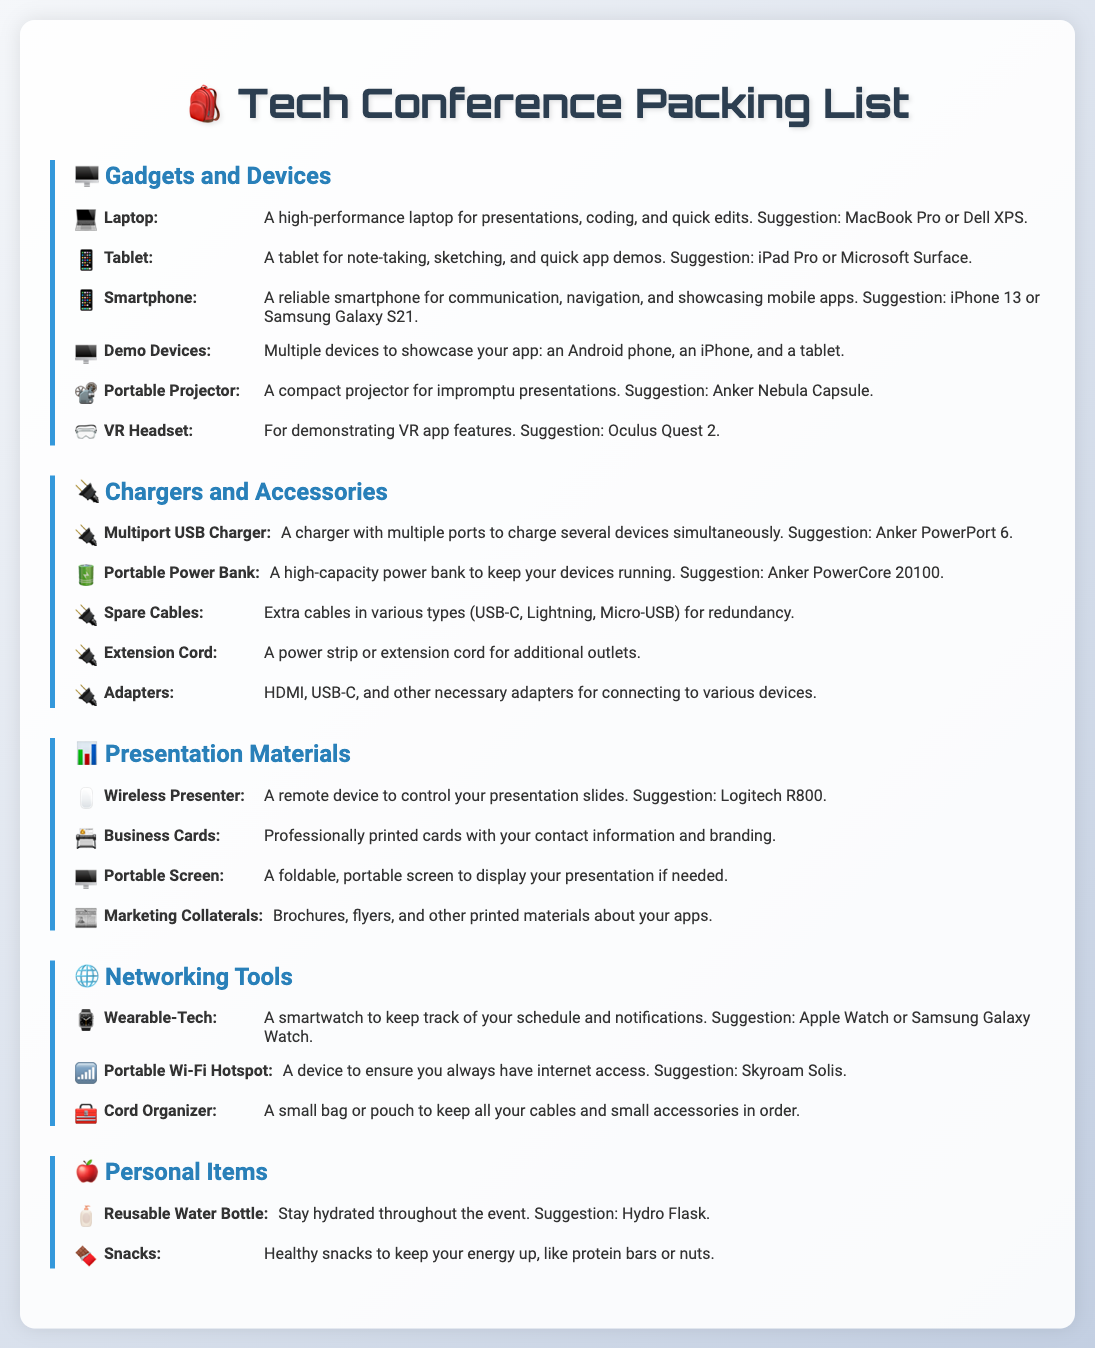What is the suggested laptop model? The document lists a suggestion for a high-performance laptop model in the gadgets section.
Answer: MacBook Pro or Dell XPS What is a recommended portable power bank? The suggested portable power bank is mentioned in the chargers and accessories section.
Answer: Anker PowerCore 20100 How many demo devices are recommended? The gadgets section specifies the number of demo devices you should bring to showcase your app.
Answer: Multiple devices What should you use for presenting your slides? The document suggests a specific device for controlling presentation slides under presentation materials.
Answer: Logitech R800 What type of water bottle is recommended? The personal items section includes a recommendation for staying hydrated during the event.
Answer: Hydro Flask Which wearable tech is suggested? The networking tools category specifies a type of wearable tech to help keep track of notifications.
Answer: Apple Watch or Samsung Galaxy Watch What device can ensure you have internet access? The networking tools section mentions a specific type of device for maintaining internet access.
Answer: Portable Wi-Fi Hotspot What is needed for note-taking and sketching? The gadgets section includes a category for a device that aids in note-taking and sketching.
Answer: Tablet How should you keep your cables organized? The networking tools section suggests an item to keep your cords tidy.
Answer: Cord Organizer 